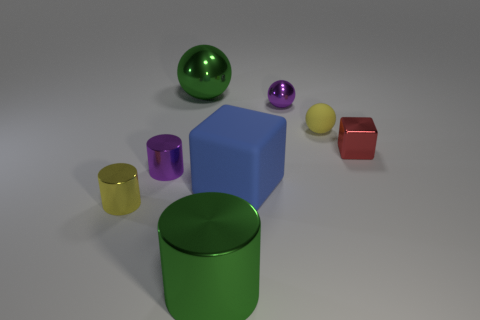Subtract all red cylinders. Subtract all red cubes. How many cylinders are left? 3 Add 2 small blocks. How many objects exist? 10 Subtract all balls. How many objects are left? 5 Subtract 0 brown cylinders. How many objects are left? 8 Subtract all small blue metallic cubes. Subtract all red metal objects. How many objects are left? 7 Add 2 green metal things. How many green metal things are left? 4 Add 2 rubber things. How many rubber things exist? 4 